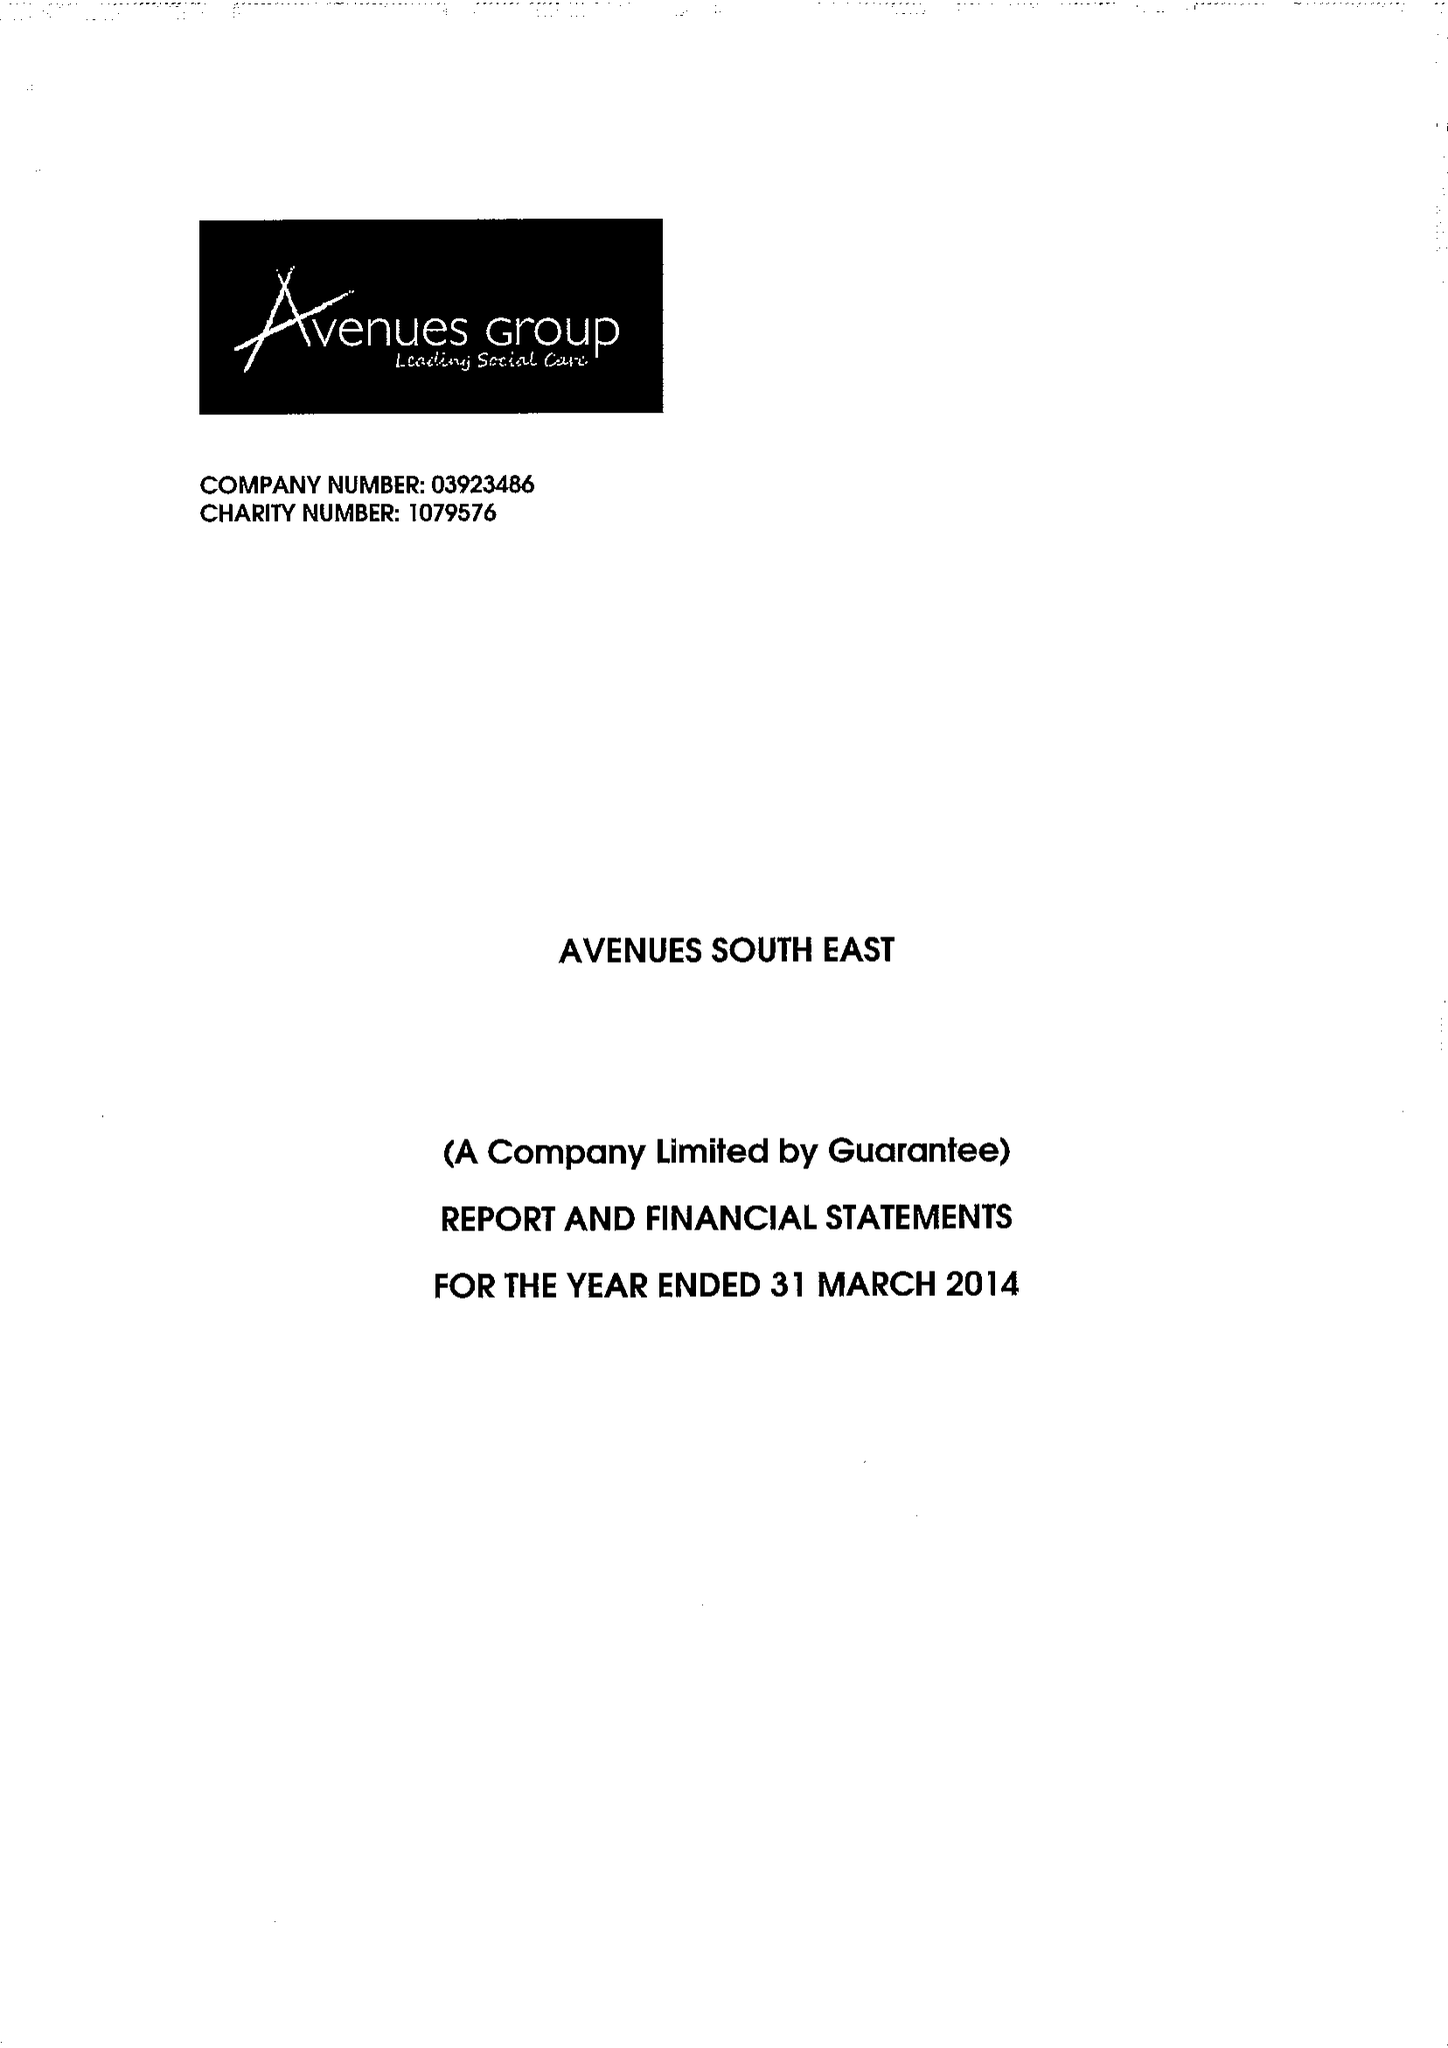What is the value for the address__post_town?
Answer the question using a single word or phrase. SIDCUP 